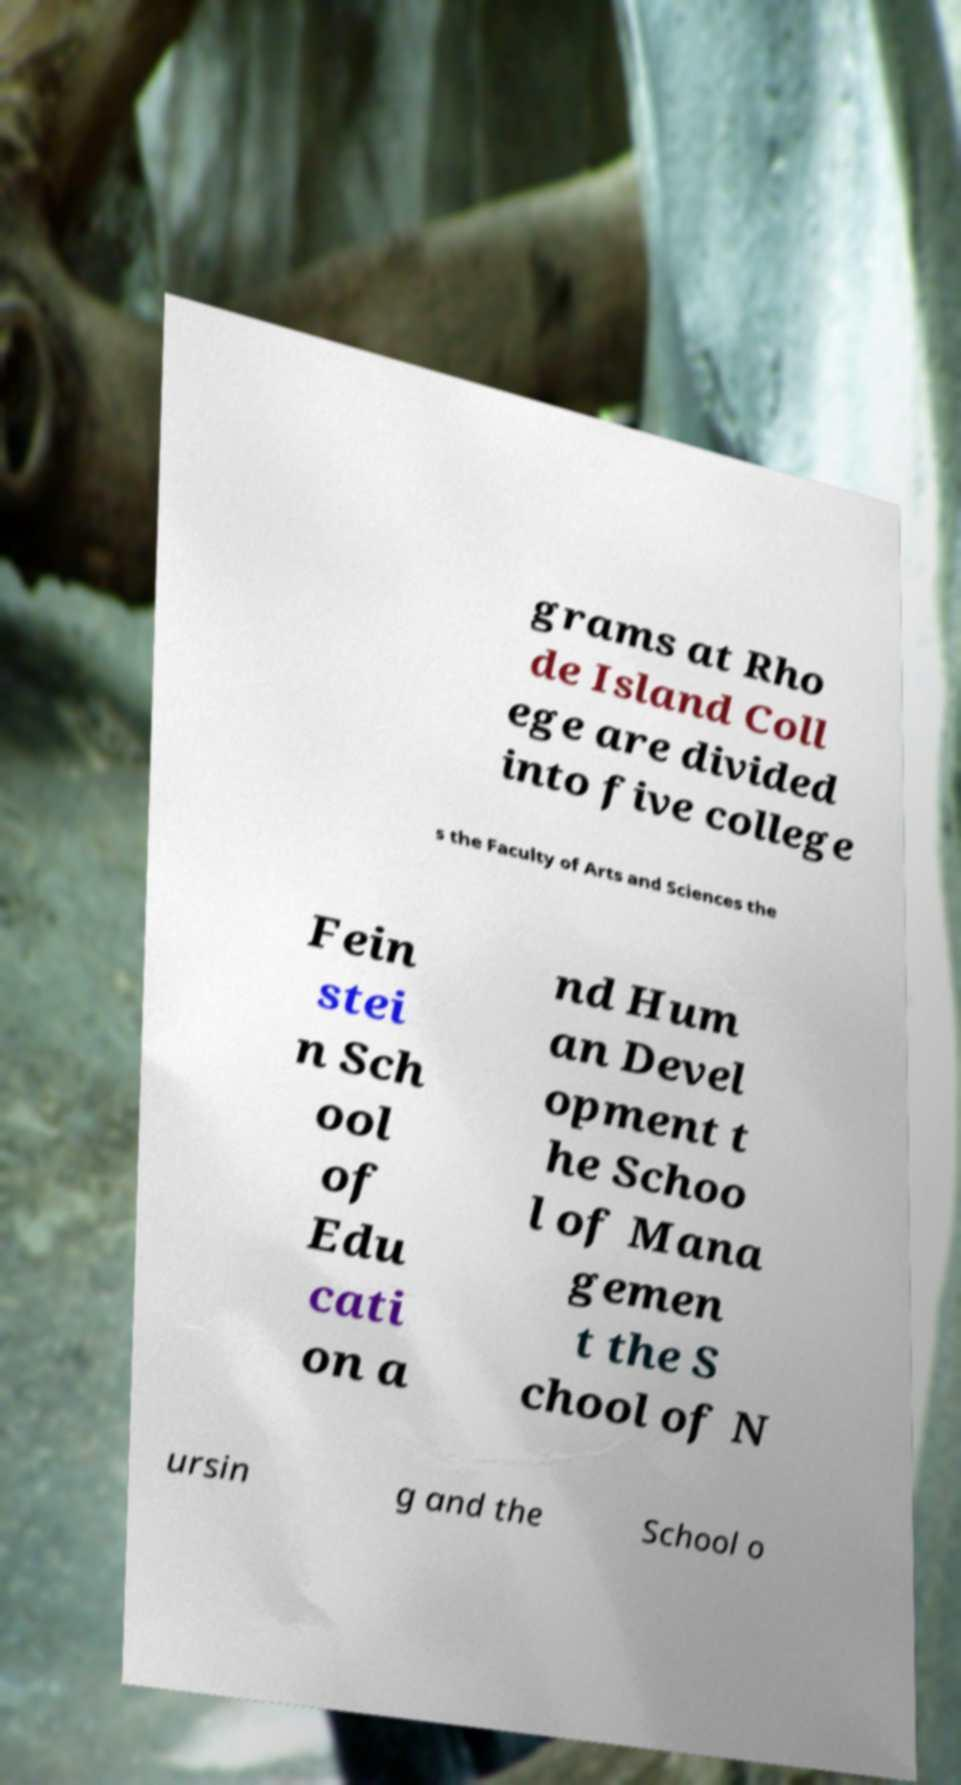Please identify and transcribe the text found in this image. grams at Rho de Island Coll ege are divided into five college s the Faculty of Arts and Sciences the Fein stei n Sch ool of Edu cati on a nd Hum an Devel opment t he Schoo l of Mana gemen t the S chool of N ursin g and the School o 